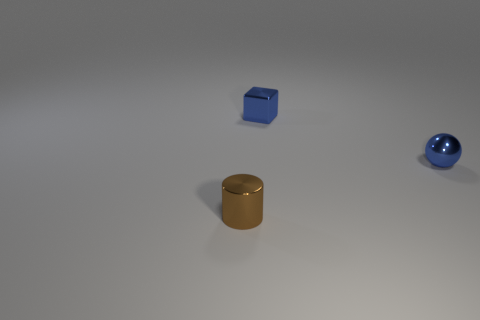Subtract all brown balls. Subtract all purple cubes. How many balls are left? 1 Add 3 large cyan rubber spheres. How many objects exist? 6 Subtract all cubes. How many objects are left? 2 Add 1 large red rubber spheres. How many large red rubber spheres exist? 1 Subtract 0 gray cubes. How many objects are left? 3 Subtract all tiny brown shiny cylinders. Subtract all tiny brown objects. How many objects are left? 1 Add 3 tiny blue things. How many tiny blue things are left? 5 